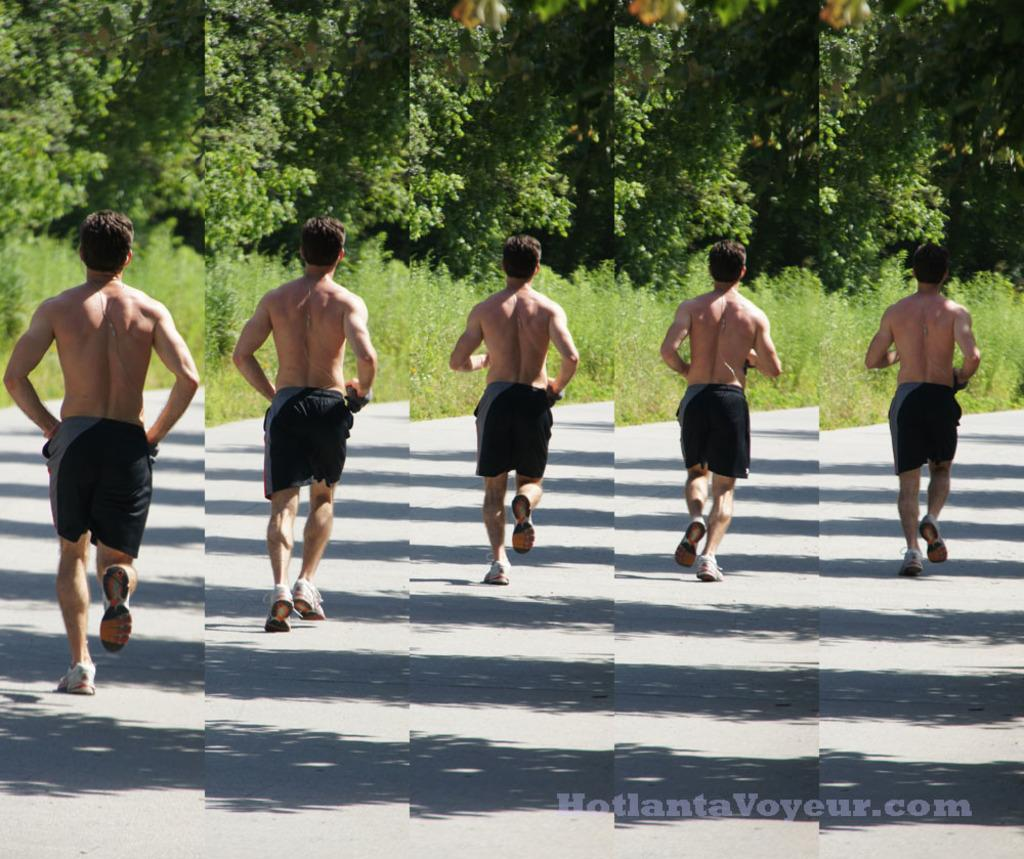What is the main subject of the image? The image contains a collage of five pictures. Can you describe one of the pictures in the collage? One of the pictures in the collage shows a person wearing shorts and running. What type of natural elements can be seen in the collage? There are trees and plants visible in the collage. What type of comfort can be seen in the image? There is no reference to comfort in the image, as it is a collage of pictures and does not depict any objects or situations related to comfort. 